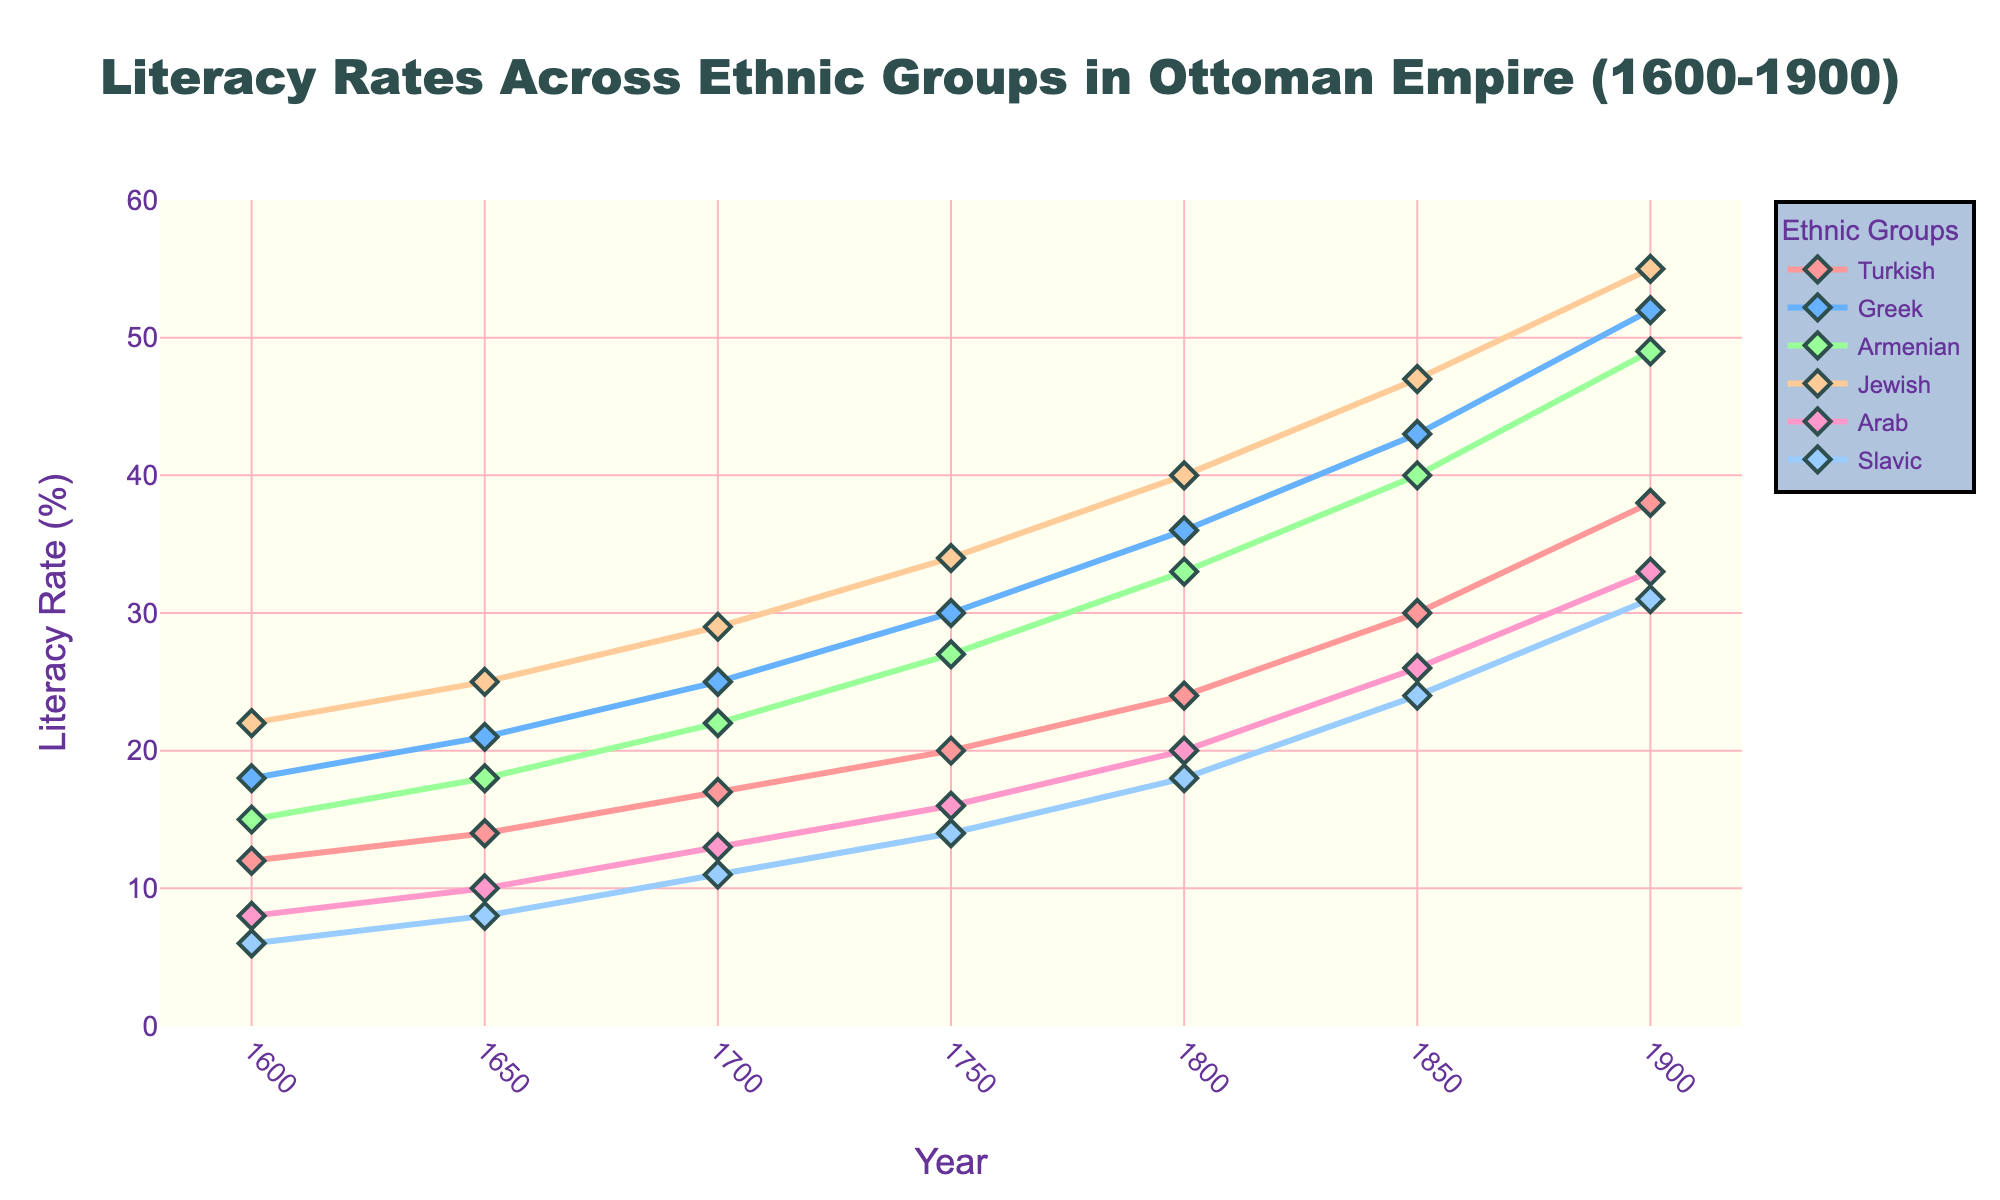What's the general trend in the literacy rates for all ethnic groups from 1600 to 1900? Over the 300-year period, literacy rates for all ethnic groups show an upward trend. By examining the trajectory of the lines for each group, it is clear that literacy rates increase steadily over time.
Answer: Upward trend Which ethnic group had the highest literacy rate in 1800? In 1800, the literacy rates for the ethnic groups can be visually compared. The Jewish group has the highest literacy rate, represented by the line reaching the peak value among all groups.
Answer: Jewish Which ethnic group experienced the largest increase in literacy rates between 1700 and 1900? To determine the largest increase, compute the difference in literacy rates for each ethnic group between 1700 and 1900. The group with the highest difference is the one that experienced the largest increase.
Answer: Turkish By how many percentage points did the literacy rate for the Armenian group increase from 1750 to 1850? Subtract the literacy rate in 1750 from the literacy rate in 1850 for the Armenian group. Difference = 40 (1850) - 27 (1750) = 13.
Answer: 13 Compare the literacy rates between the Turkish and Greek groups in 1650. Which group has a higher rate and by how much? From the figure, read the literacy rates for both Turkish and Greek in 1650. Greek has a literacy rate of 21, while Turkish has 14. The difference is 21 - 14 = 7.
Answer: Greek by 7 Which ethnic group had the lowest increase in literacy rates from 1600 to 1900, and what was the total increase? Calculate the increase from 1600 to 1900 for each ethnic group. The ethnic group with the smallest increase can be identified. Total increase for Slavic group is 31 (1900) - 6 (1600) = 25.
Answer: Slavic, 25 What is the average literacy rate for the Arab group across all recorded years? Sum the literacy rates of the Arab group across all years and divide by the number of recorded years (6). (8 + 10 + 13 + 16 + 20 + 26 + 33) / 7 = 126 / 7.
Answer: 18 Which period (50-year segments) saw the most significant growth in literacy rates for the Greek group? Compare the difference in literacy rates for the Greek group in each 50-year segment: 1600-1650, 1650-1700, etc. The most significant growth is determined by the highest difference. 1850-1900 saw the largest increase of 9.
Answer: 1850-1900 What can be inferred about the relative pace of literacy rate increases among different ethnic groups? By examining the slopes of the lines representing each ethnic group, it can be inferred that the pace at which literacy rates increased varied. Steeper slopes indicate faster increases.
Answer: Varied pace, steeper for some groups like Turkish, Greek, and Jewish 